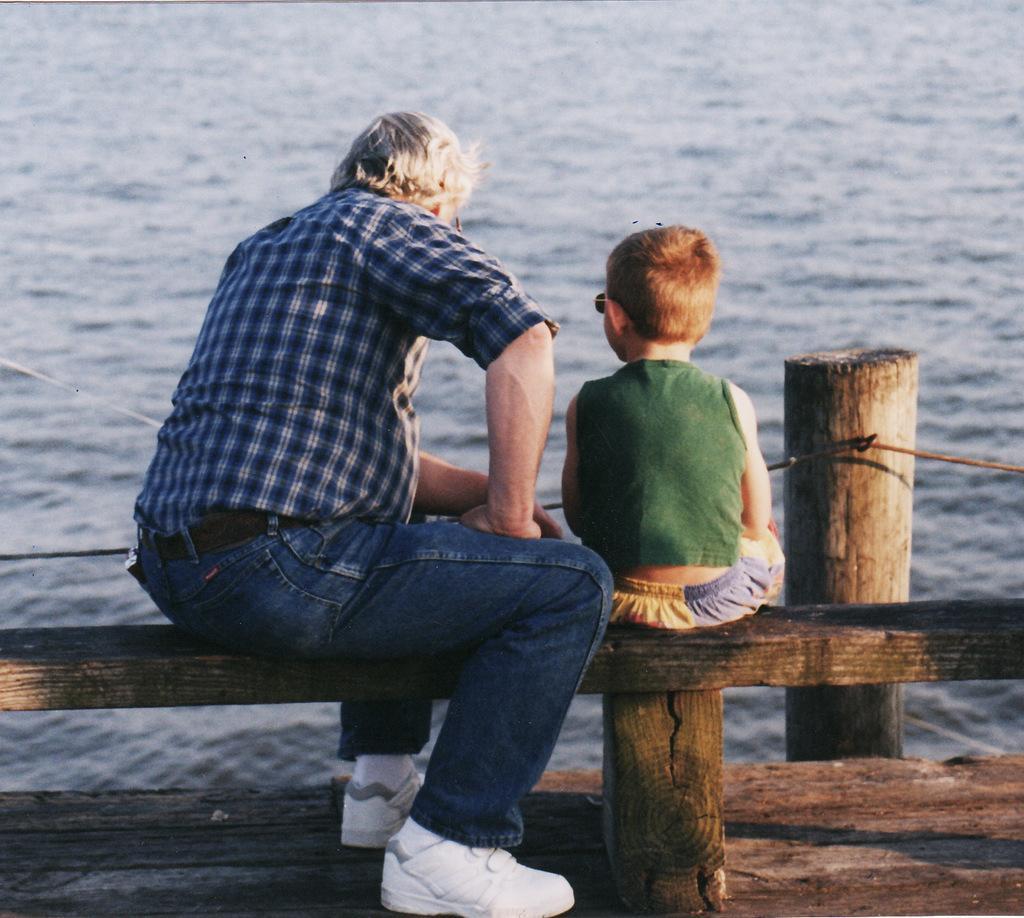In one or two sentences, can you explain what this image depicts? In this picture there is a person and a kid sitting on a wooden object and there is water in front of them. 